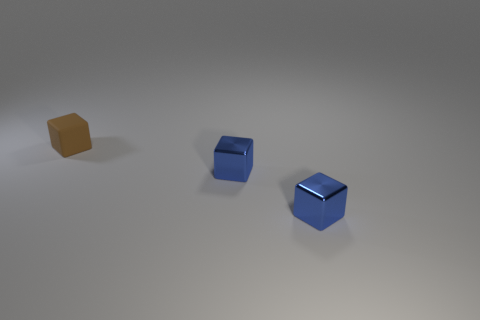Add 1 tiny things. How many objects exist? 4 Add 2 blue metal blocks. How many blue metal blocks exist? 4 Subtract 2 blue cubes. How many objects are left? 1 Subtract all large things. Subtract all small matte cubes. How many objects are left? 2 Add 3 cubes. How many cubes are left? 6 